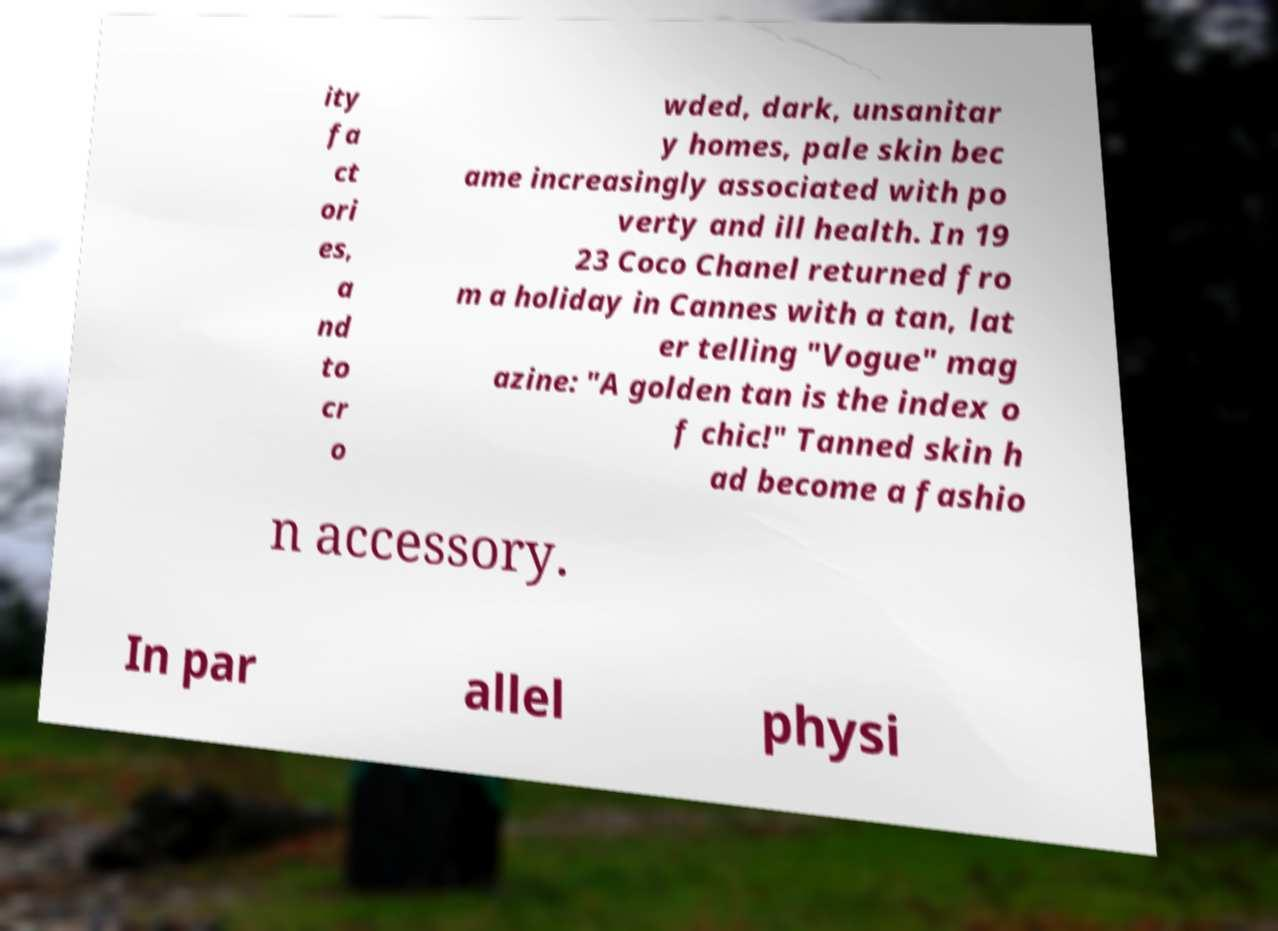Could you assist in decoding the text presented in this image and type it out clearly? ity fa ct ori es, a nd to cr o wded, dark, unsanitar y homes, pale skin bec ame increasingly associated with po verty and ill health. In 19 23 Coco Chanel returned fro m a holiday in Cannes with a tan, lat er telling "Vogue" mag azine: "A golden tan is the index o f chic!" Tanned skin h ad become a fashio n accessory. In par allel physi 